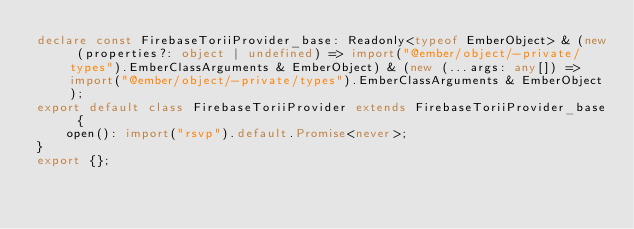Convert code to text. <code><loc_0><loc_0><loc_500><loc_500><_TypeScript_>declare const FirebaseToriiProvider_base: Readonly<typeof EmberObject> & (new (properties?: object | undefined) => import("@ember/object/-private/types").EmberClassArguments & EmberObject) & (new (...args: any[]) => import("@ember/object/-private/types").EmberClassArguments & EmberObject);
export default class FirebaseToriiProvider extends FirebaseToriiProvider_base {
    open(): import("rsvp").default.Promise<never>;
}
export {};
</code> 